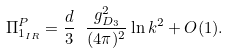Convert formula to latex. <formula><loc_0><loc_0><loc_500><loc_500>\Pi _ { 1 _ { I R } } ^ { P } = \frac { d } { 3 } \ \frac { g _ { D _ { 3 } } ^ { 2 } } { ( 4 \pi ) ^ { 2 } } \ln k ^ { 2 } + O ( 1 ) .</formula> 